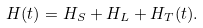<formula> <loc_0><loc_0><loc_500><loc_500>H ( t ) = H _ { S } + H _ { L } + H _ { T } ( t ) .</formula> 